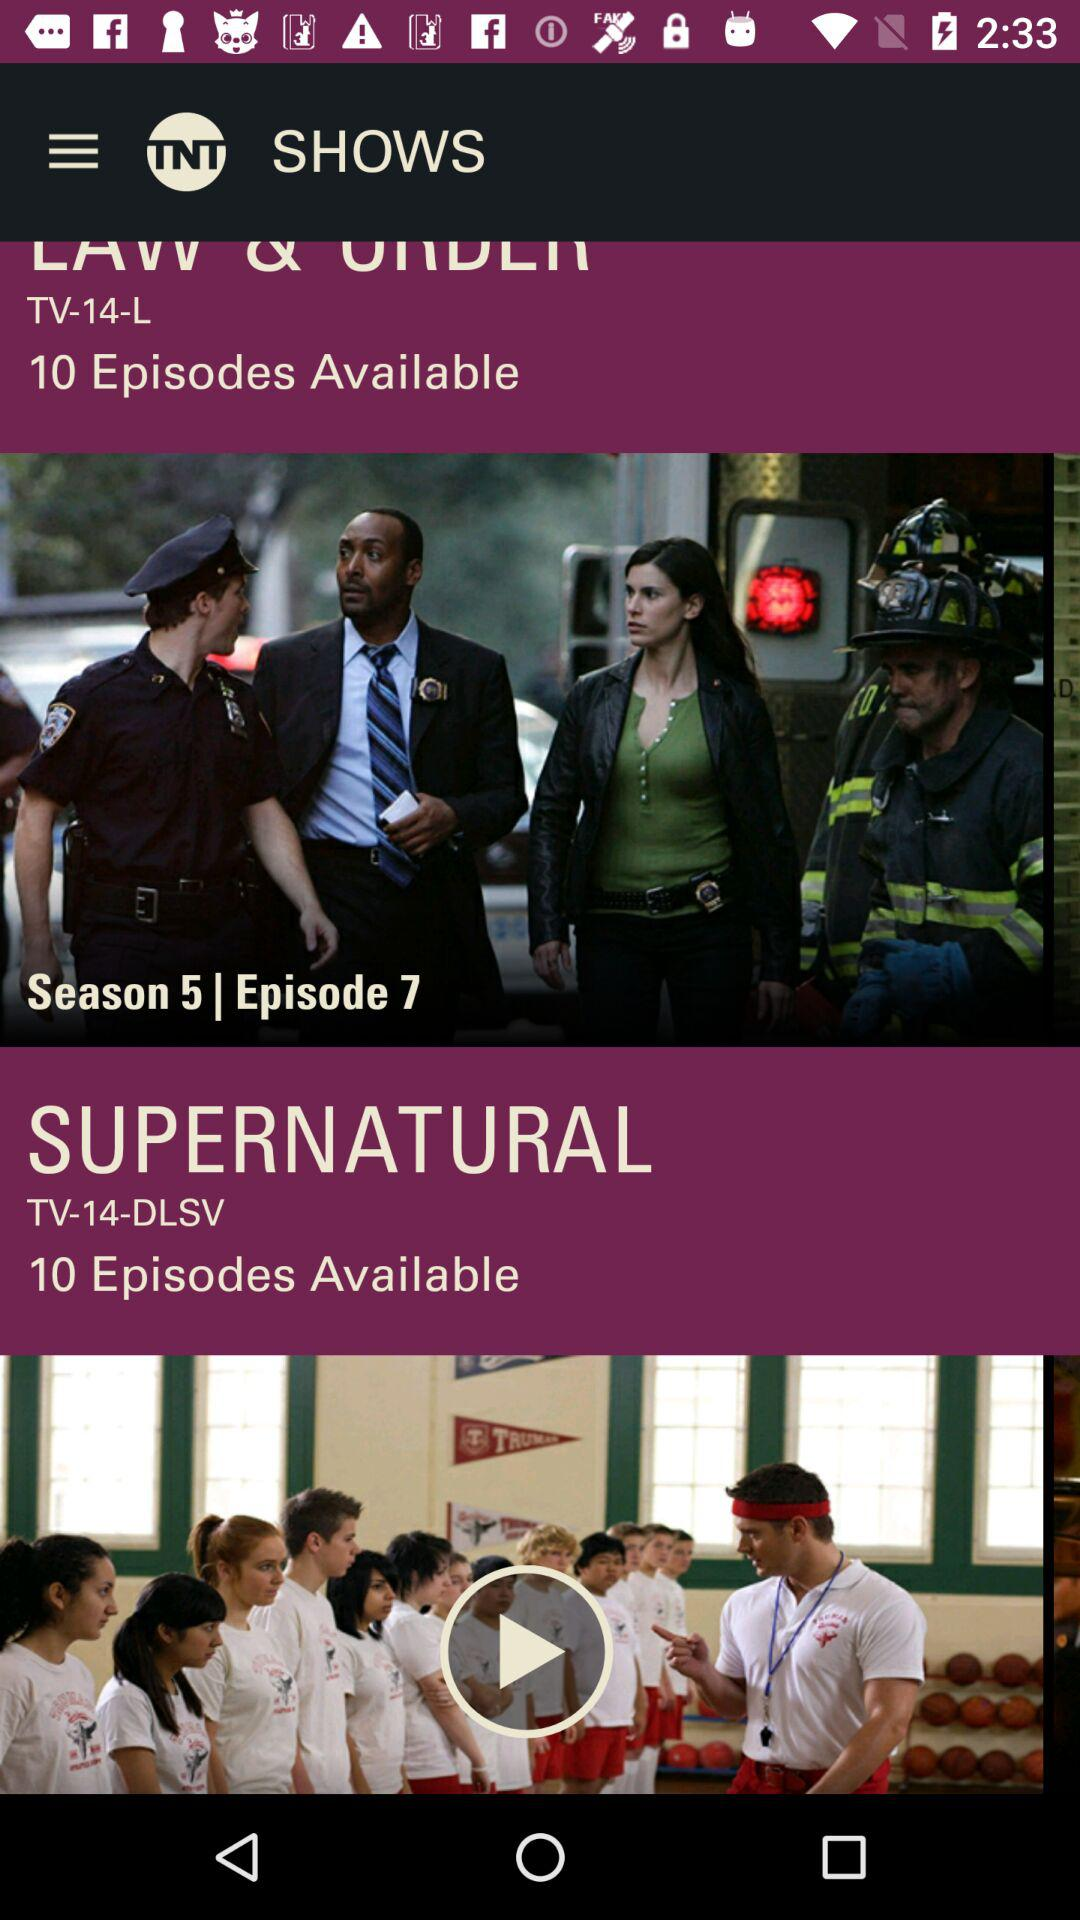What is the application name? The application name is "TNT". 